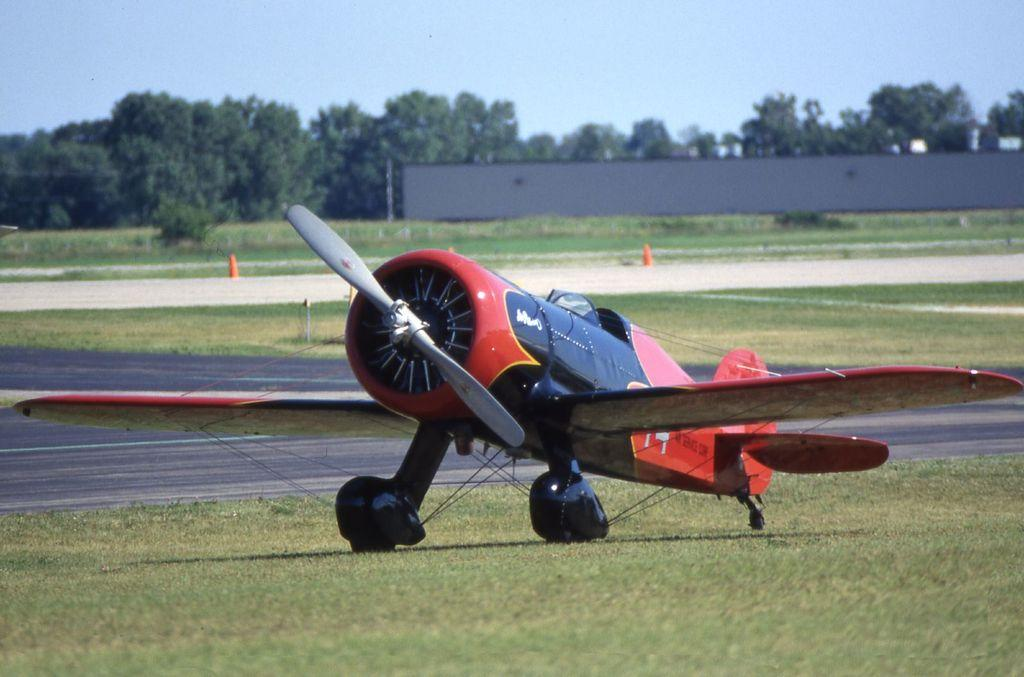What is the main subject of the image? The main subject of the image is an airplane. Where is the airplane located in the image? The airplane is on the ground. What can be seen in the background of the image? In the background of the image, there is grass, trees, a wall, and the sky. Can you see a river flowing behind the airplane in the image? No, there is no river visible in the image. 